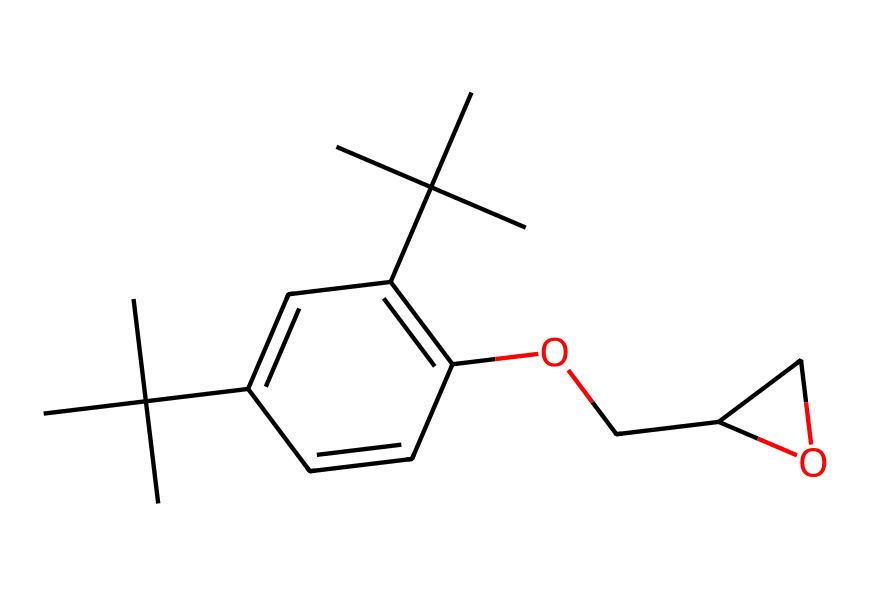What is the total number of carbon atoms in this compound? Counting the carbon atoms in the provided SMILES representation reveals there are 20 carbon atoms. There are numerous branching and cyclic structures, but each carbon can be identified by recognizing "C" in the SMILES.
Answer: 20 How many hydroxyl (OH) groups are present in this molecule? In the SMILES string, the "OCC" indicates the presence of an ether link (O) and the "C" adjacent to it has another "O" connected to it, which is part of the hydroxyl group. Thus, there is one hydroxyl group present in the structure.
Answer: 1 What type of structure does this compound suggest (cyclic, acyclic, or both)? The SMILES structure shows both cyclic (the presence of a ring with “C1”) and acyclic components (linear chains and branching). Thus, the compound exhibits both types of structures.
Answer: both Identify the functional group present in this compound. Analyzing the structure reveals the presence of an ether group (–O–) and a hydroxyl group (–OH). The clear indicators in the SMILES representation help identify these functional groups.
Answer: ether and hydroxyl How many double bonds are present in the compound? The SMILES string indicates double bonds with the "=" sign. There are two instances of double bonds, specifically within the aromatic ring indicated by "C=C."
Answer: 2 What is the role of this compound in structural adhesives? Given that the compound is an epoxy resin, it acts as a cross-linking agent due to its reactive functional groups, which promote strong adhesion and structural integrity when cured.
Answer: cross-linking agent 